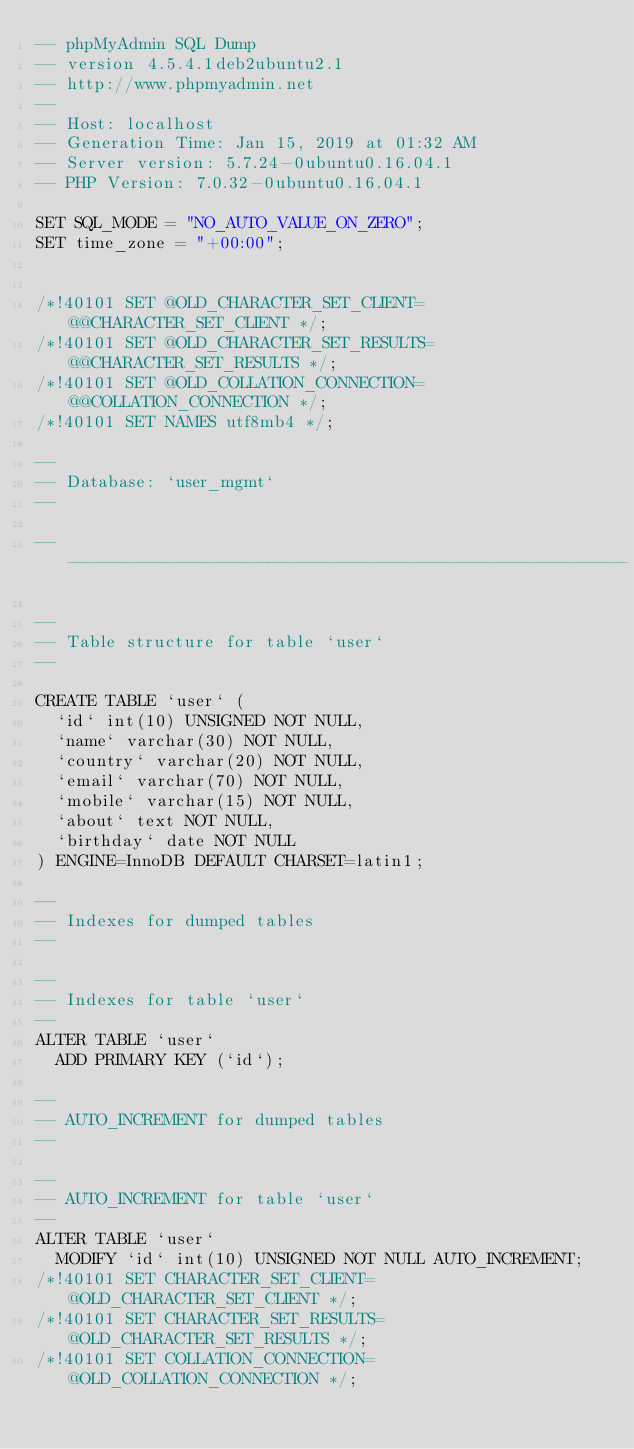<code> <loc_0><loc_0><loc_500><loc_500><_SQL_>-- phpMyAdmin SQL Dump
-- version 4.5.4.1deb2ubuntu2.1
-- http://www.phpmyadmin.net
--
-- Host: localhost
-- Generation Time: Jan 15, 2019 at 01:32 AM
-- Server version: 5.7.24-0ubuntu0.16.04.1
-- PHP Version: 7.0.32-0ubuntu0.16.04.1

SET SQL_MODE = "NO_AUTO_VALUE_ON_ZERO";
SET time_zone = "+00:00";


/*!40101 SET @OLD_CHARACTER_SET_CLIENT=@@CHARACTER_SET_CLIENT */;
/*!40101 SET @OLD_CHARACTER_SET_RESULTS=@@CHARACTER_SET_RESULTS */;
/*!40101 SET @OLD_COLLATION_CONNECTION=@@COLLATION_CONNECTION */;
/*!40101 SET NAMES utf8mb4 */;

--
-- Database: `user_mgmt`
--

-- --------------------------------------------------------

--
-- Table structure for table `user`
--

CREATE TABLE `user` (
  `id` int(10) UNSIGNED NOT NULL,
  `name` varchar(30) NOT NULL,
  `country` varchar(20) NOT NULL,
  `email` varchar(70) NOT NULL,
  `mobile` varchar(15) NOT NULL,
  `about` text NOT NULL,
  `birthday` date NOT NULL
) ENGINE=InnoDB DEFAULT CHARSET=latin1;

--
-- Indexes for dumped tables
--

--
-- Indexes for table `user`
--
ALTER TABLE `user`
  ADD PRIMARY KEY (`id`);

--
-- AUTO_INCREMENT for dumped tables
--

--
-- AUTO_INCREMENT for table `user`
--
ALTER TABLE `user`
  MODIFY `id` int(10) UNSIGNED NOT NULL AUTO_INCREMENT;
/*!40101 SET CHARACTER_SET_CLIENT=@OLD_CHARACTER_SET_CLIENT */;
/*!40101 SET CHARACTER_SET_RESULTS=@OLD_CHARACTER_SET_RESULTS */;
/*!40101 SET COLLATION_CONNECTION=@OLD_COLLATION_CONNECTION */;
</code> 